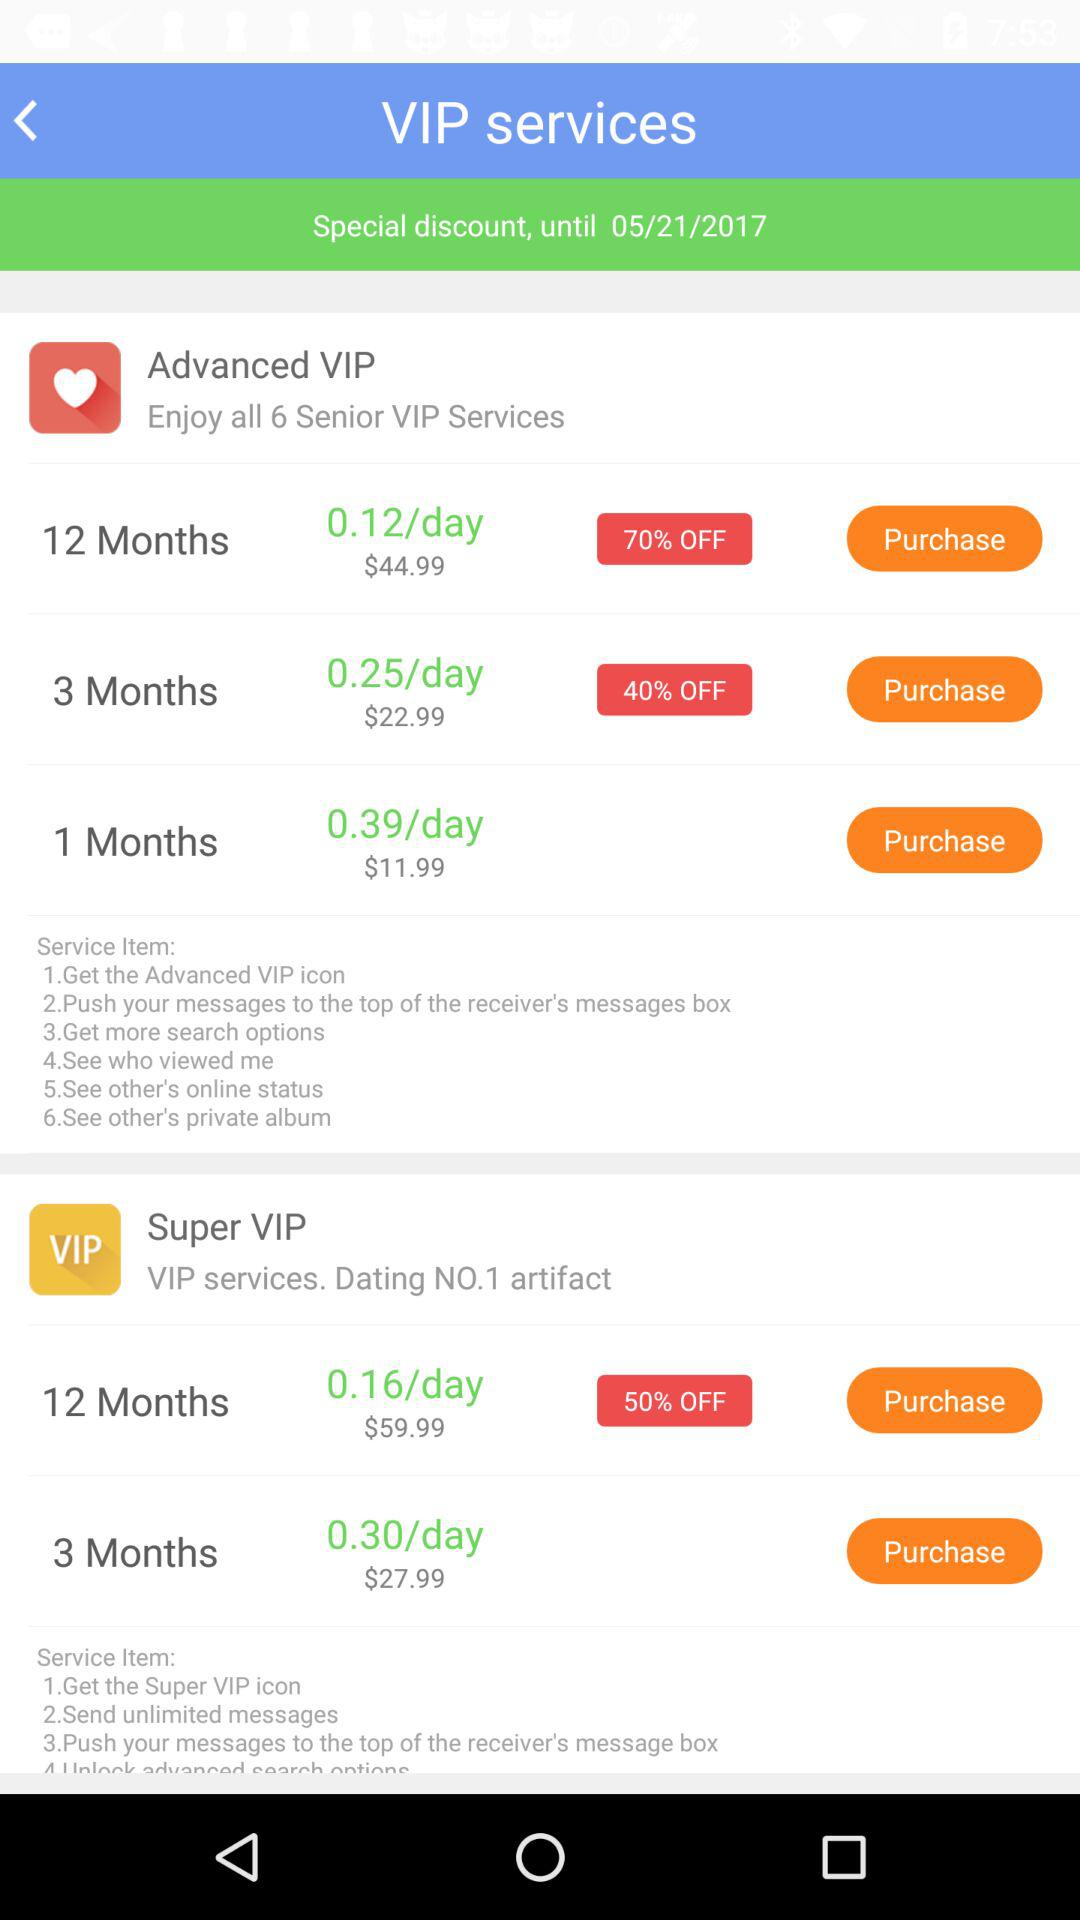What are the service items that I will get in the "Advanced VIP" subscription? The service items that you will get are "Get the Advanced VIP icon", "Push your messages to the top of the receiver's messages box", "Get more search options", "See who viewed me", "See other's online status" and "See other's private album". 